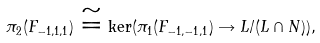Convert formula to latex. <formula><loc_0><loc_0><loc_500><loc_500>\pi _ { 2 } ( F _ { - 1 , 1 , 1 } ) \cong \ker ( \pi _ { 1 } ( F _ { - 1 , - 1 , 1 } ) \rightarrow L / ( L \cap N ) ) ,</formula> 